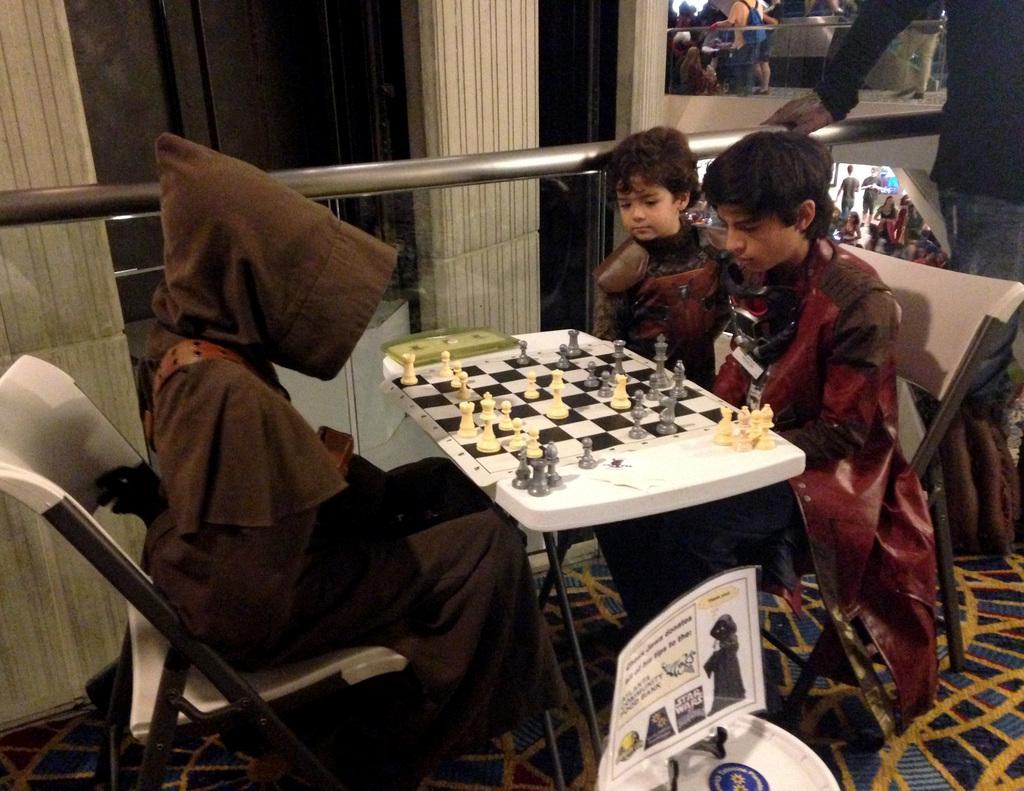In one or two sentences, can you explain what this image depicts? This picture is of inside. On the right corner there is a man standing and on the right there is a person sitting on the chair, beside him there is a boy seems to be standing. In the center there is a table on the top of which the chess board is placed. On the left there is a person sitting on the chair. In the background we can see group of people. 